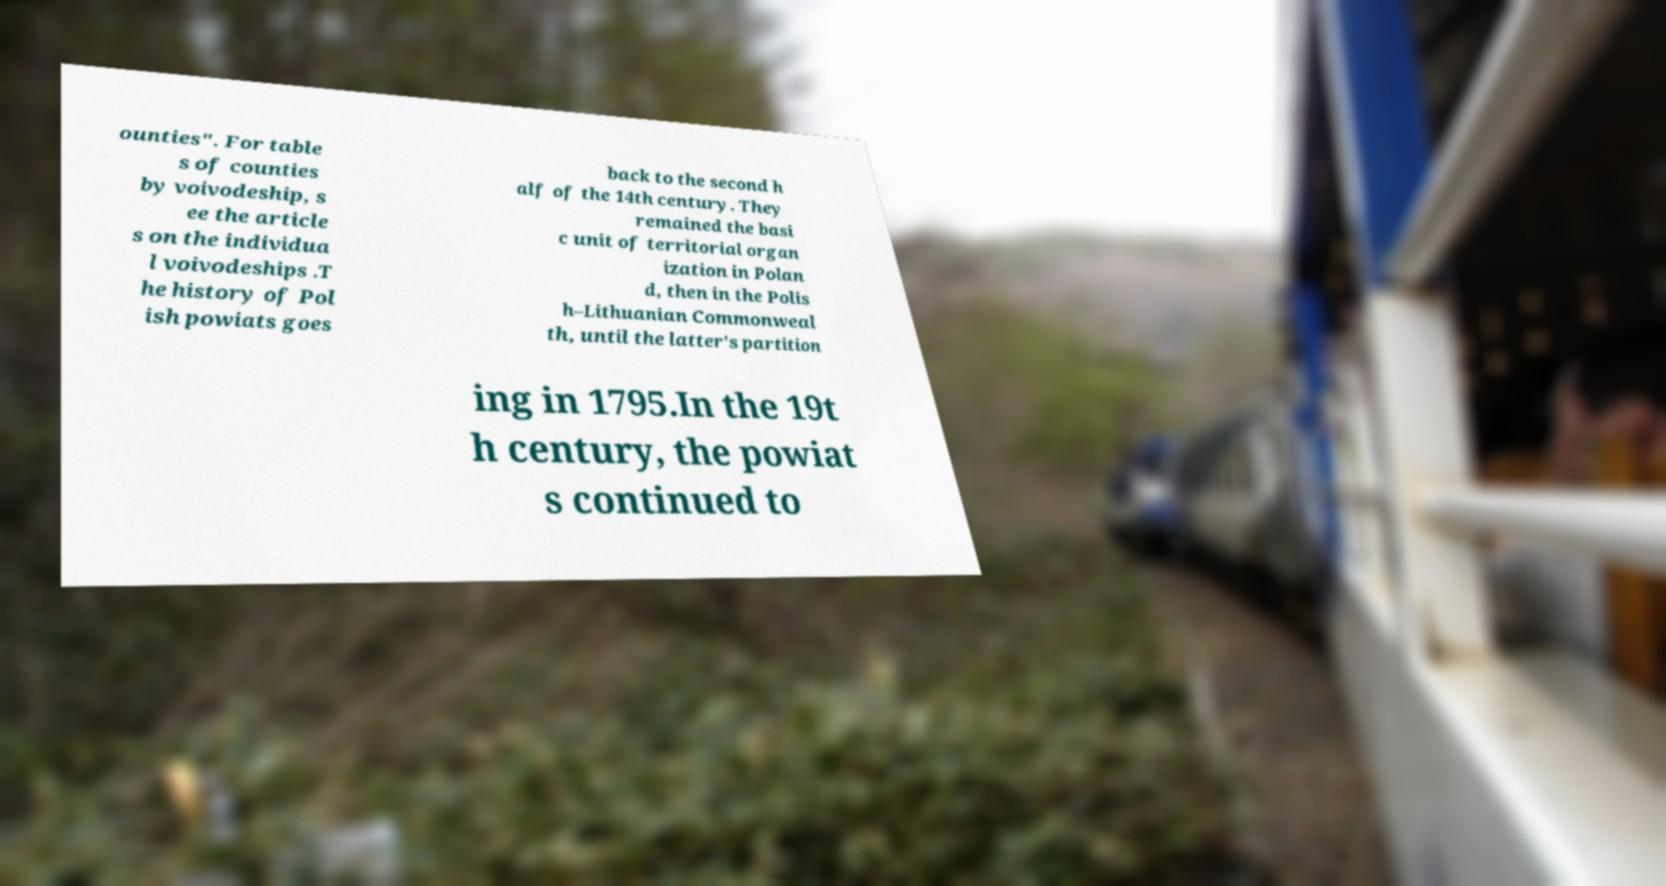Please read and relay the text visible in this image. What does it say? ounties". For table s of counties by voivodeship, s ee the article s on the individua l voivodeships .T he history of Pol ish powiats goes back to the second h alf of the 14th century. They remained the basi c unit of territorial organ ization in Polan d, then in the Polis h–Lithuanian Commonweal th, until the latter's partition ing in 1795.In the 19t h century, the powiat s continued to 